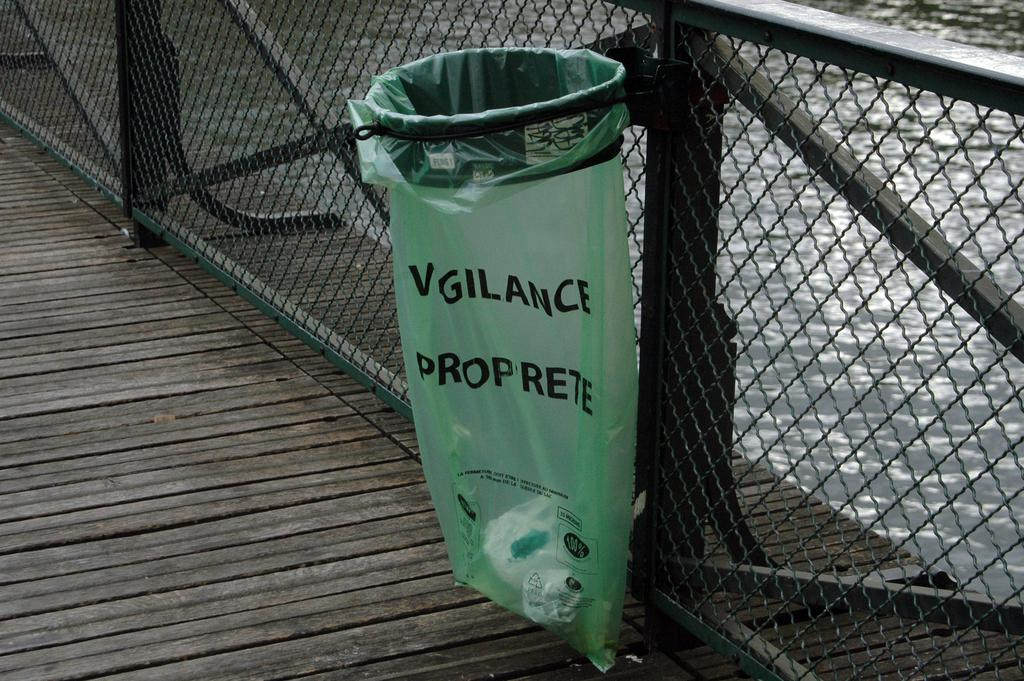<image>
Present a compact description of the photo's key features. Green bag that says Vigilance hanging on a fence. 